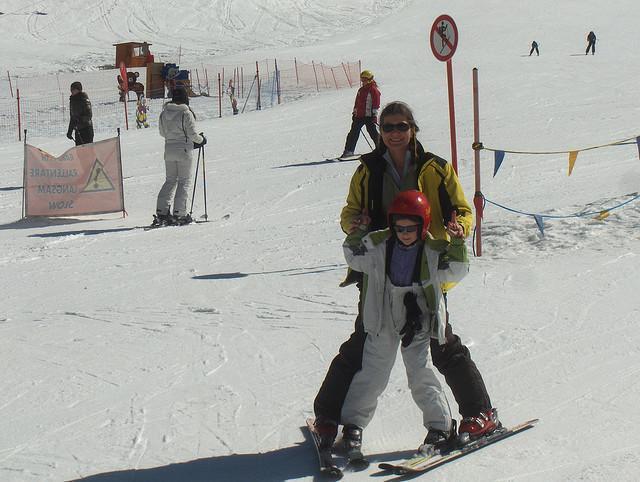How many people are in the picture?
Give a very brief answer. 3. 